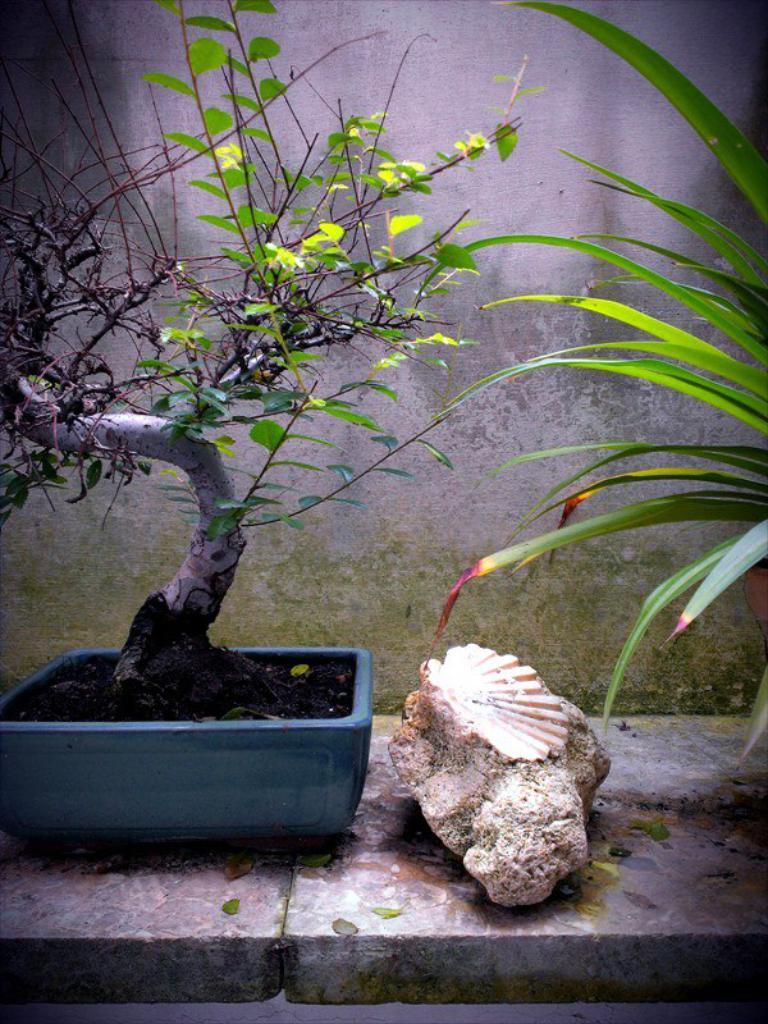What type of plant can be seen in the image? There is a plant in the image. Where is the plant located? The plant is in a plant pot. What color is the plant pot? The plant pot is blue. What is beside the plant pot? There is a stone beside the plant pot. What can be seen in the background of the image? There is a wall in the background of the image. What type of poison is the crow using to attack the plant in the image? There is no crow or poison present in the image; it features a plant in a blue plant pot with a stone beside it and a wall in the background. 